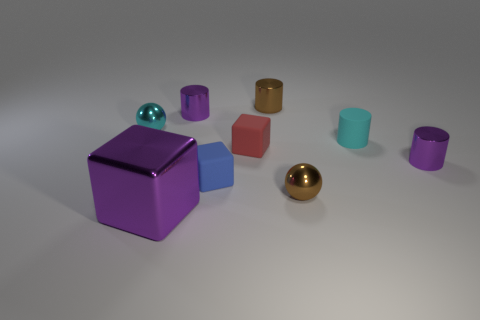Do the red thing and the big purple thing that is on the left side of the small brown sphere have the same shape?
Provide a succinct answer. Yes. How many matte things are brown cylinders or small yellow objects?
Your answer should be compact. 0. The cylinder to the right of the matte thing to the right of the small red thing behind the metal cube is what color?
Keep it short and to the point. Purple. How many other things are made of the same material as the small blue block?
Make the answer very short. 2. Do the small red rubber object that is behind the big metal object and the blue thing have the same shape?
Your answer should be compact. Yes. How many small things are either gray metal spheres or brown metallic cylinders?
Make the answer very short. 1. Is the number of cyan rubber objects that are left of the brown cylinder the same as the number of blue things behind the blue rubber thing?
Your answer should be compact. Yes. How many other objects are the same color as the metal cube?
Offer a very short reply. 2. Does the large metallic block have the same color as the cylinder that is to the left of the tiny blue cube?
Your response must be concise. Yes. What number of yellow objects are either matte things or spheres?
Your answer should be very brief. 0. 